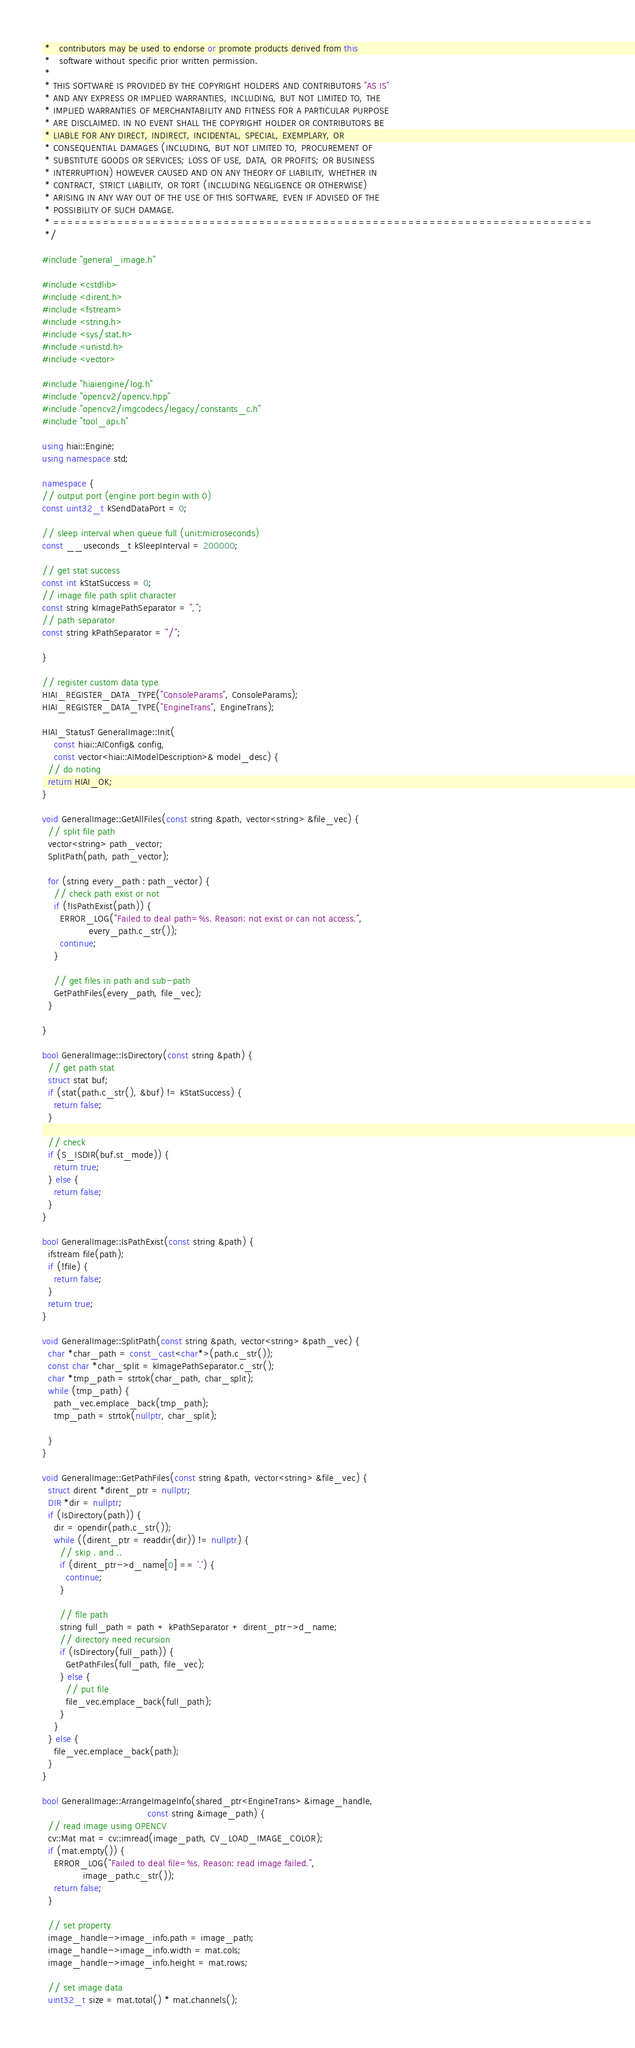Convert code to text. <code><loc_0><loc_0><loc_500><loc_500><_C++_> *   contributors may be used to endorse or promote products derived from this
 *   software without specific prior written permission.
 *
 * THIS SOFTWARE IS PROVIDED BY THE COPYRIGHT HOLDERS AND CONTRIBUTORS "AS IS"
 * AND ANY EXPRESS OR IMPLIED WARRANTIES, INCLUDING, BUT NOT LIMITED TO, THE
 * IMPLIED WARRANTIES OF MERCHANTABILITY AND FITNESS FOR A PARTICULAR PURPOSE
 * ARE DISCLAIMED. IN NO EVENT SHALL THE COPYRIGHT HOLDER OR CONTRIBUTORS BE
 * LIABLE FOR ANY DIRECT, INDIRECT, INCIDENTAL, SPECIAL, EXEMPLARY, OR
 * CONSEQUENTIAL DAMAGES (INCLUDING, BUT NOT LIMITED TO, PROCUREMENT OF
 * SUBSTITUTE GOODS OR SERVICES; LOSS OF USE, DATA, OR PROFITS; OR BUSINESS
 * INTERRUPTION) HOWEVER CAUSED AND ON ANY THEORY OF LIABILITY, WHETHER IN
 * CONTRACT, STRICT LIABILITY, OR TORT (INCLUDING NEGLIGENCE OR OTHERWISE)
 * ARISING IN ANY WAY OUT OF THE USE OF THIS SOFTWARE, EVEN IF ADVISED OF THE
 * POSSIBILITY OF SUCH DAMAGE.
 * ============================================================================
 */

#include "general_image.h"

#include <cstdlib>
#include <dirent.h>
#include <fstream>
#include <string.h>
#include <sys/stat.h>
#include <unistd.h>
#include <vector>

#include "hiaiengine/log.h"
#include "opencv2/opencv.hpp"
#include "opencv2/imgcodecs/legacy/constants_c.h"
#include "tool_api.h"

using hiai::Engine;
using namespace std;

namespace {
// output port (engine port begin with 0)
const uint32_t kSendDataPort = 0;

// sleep interval when queue full (unit:microseconds)
const __useconds_t kSleepInterval = 200000;

// get stat success
const int kStatSuccess = 0;
// image file path split character
const string kImagePathSeparator = ",";
// path separator
const string kPathSeparator = "/";

}

// register custom data type
HIAI_REGISTER_DATA_TYPE("ConsoleParams", ConsoleParams);
HIAI_REGISTER_DATA_TYPE("EngineTrans", EngineTrans);

HIAI_StatusT GeneralImage::Init(
    const hiai::AIConfig& config,
    const vector<hiai::AIModelDescription>& model_desc) {
  // do noting
  return HIAI_OK;
}

void GeneralImage::GetAllFiles(const string &path, vector<string> &file_vec) {
  // split file path
  vector<string> path_vector;
  SplitPath(path, path_vector);

  for (string every_path : path_vector) {
    // check path exist or not
    if (!IsPathExist(path)) {
      ERROR_LOG("Failed to deal path=%s. Reason: not exist or can not access.",
                every_path.c_str());
      continue;
    }

    // get files in path and sub-path
    GetPathFiles(every_path, file_vec);
  }

}

bool GeneralImage::IsDirectory(const string &path) {
  // get path stat
  struct stat buf;
  if (stat(path.c_str(), &buf) != kStatSuccess) {
    return false;
  }

  // check
  if (S_ISDIR(buf.st_mode)) {
    return true;
  } else {
    return false;
  }
}

bool GeneralImage::IsPathExist(const string &path) {
  ifstream file(path);
  if (!file) {
    return false;
  }
  return true;
}

void GeneralImage::SplitPath(const string &path, vector<string> &path_vec) {
  char *char_path = const_cast<char*>(path.c_str());
  const char *char_split = kImagePathSeparator.c_str();
  char *tmp_path = strtok(char_path, char_split);
  while (tmp_path) {
    path_vec.emplace_back(tmp_path);
    tmp_path = strtok(nullptr, char_split);

  }
}

void GeneralImage::GetPathFiles(const string &path, vector<string> &file_vec) {
  struct dirent *dirent_ptr = nullptr;
  DIR *dir = nullptr;
  if (IsDirectory(path)) {
    dir = opendir(path.c_str());
    while ((dirent_ptr = readdir(dir)) != nullptr) {
      // skip . and ..
      if (dirent_ptr->d_name[0] == '.') {
        continue;
      }

      // file path
      string full_path = path + kPathSeparator + dirent_ptr->d_name;
      // directory need recursion
      if (IsDirectory(full_path)) {
        GetPathFiles(full_path, file_vec);
      } else {
        // put file
        file_vec.emplace_back(full_path);
      }
    }
  } else {
    file_vec.emplace_back(path);
  }
}

bool GeneralImage::ArrangeImageInfo(shared_ptr<EngineTrans> &image_handle,
                                    const string &image_path) {
  // read image using OPENCV
  cv::Mat mat = cv::imread(image_path, CV_LOAD_IMAGE_COLOR);
  if (mat.empty()) {
    ERROR_LOG("Failed to deal file=%s. Reason: read image failed.",
              image_path.c_str());
    return false;
  }

  // set property
  image_handle->image_info.path = image_path;
  image_handle->image_info.width = mat.cols;
  image_handle->image_info.height = mat.rows;

  // set image data
  uint32_t size = mat.total() * mat.channels();</code> 